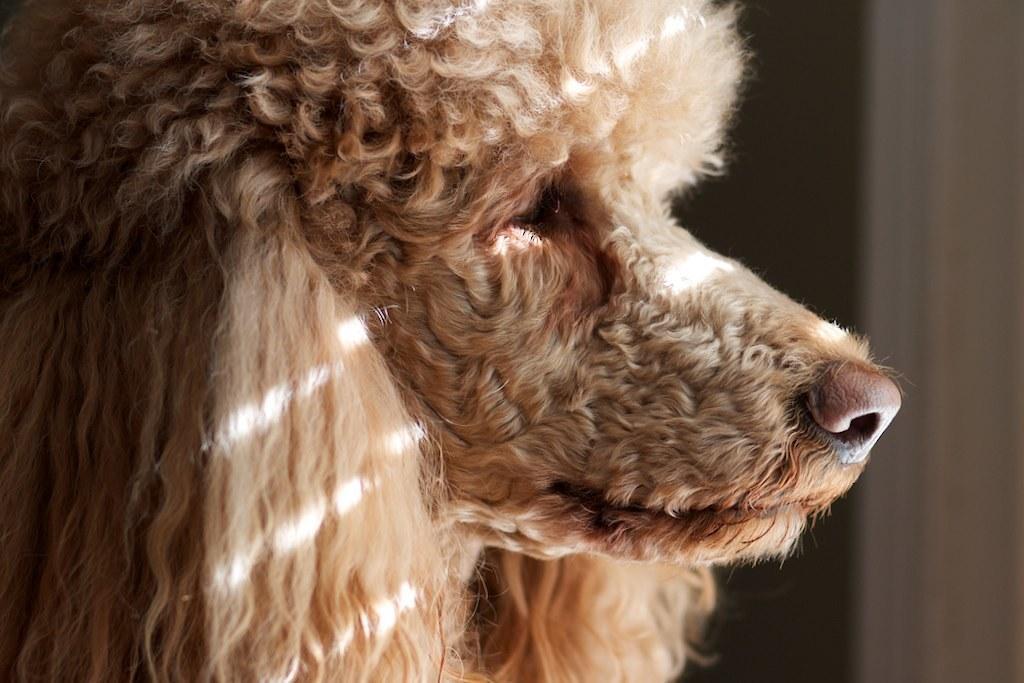In one or two sentences, can you explain what this image depicts? In this picture we can see a dog. 